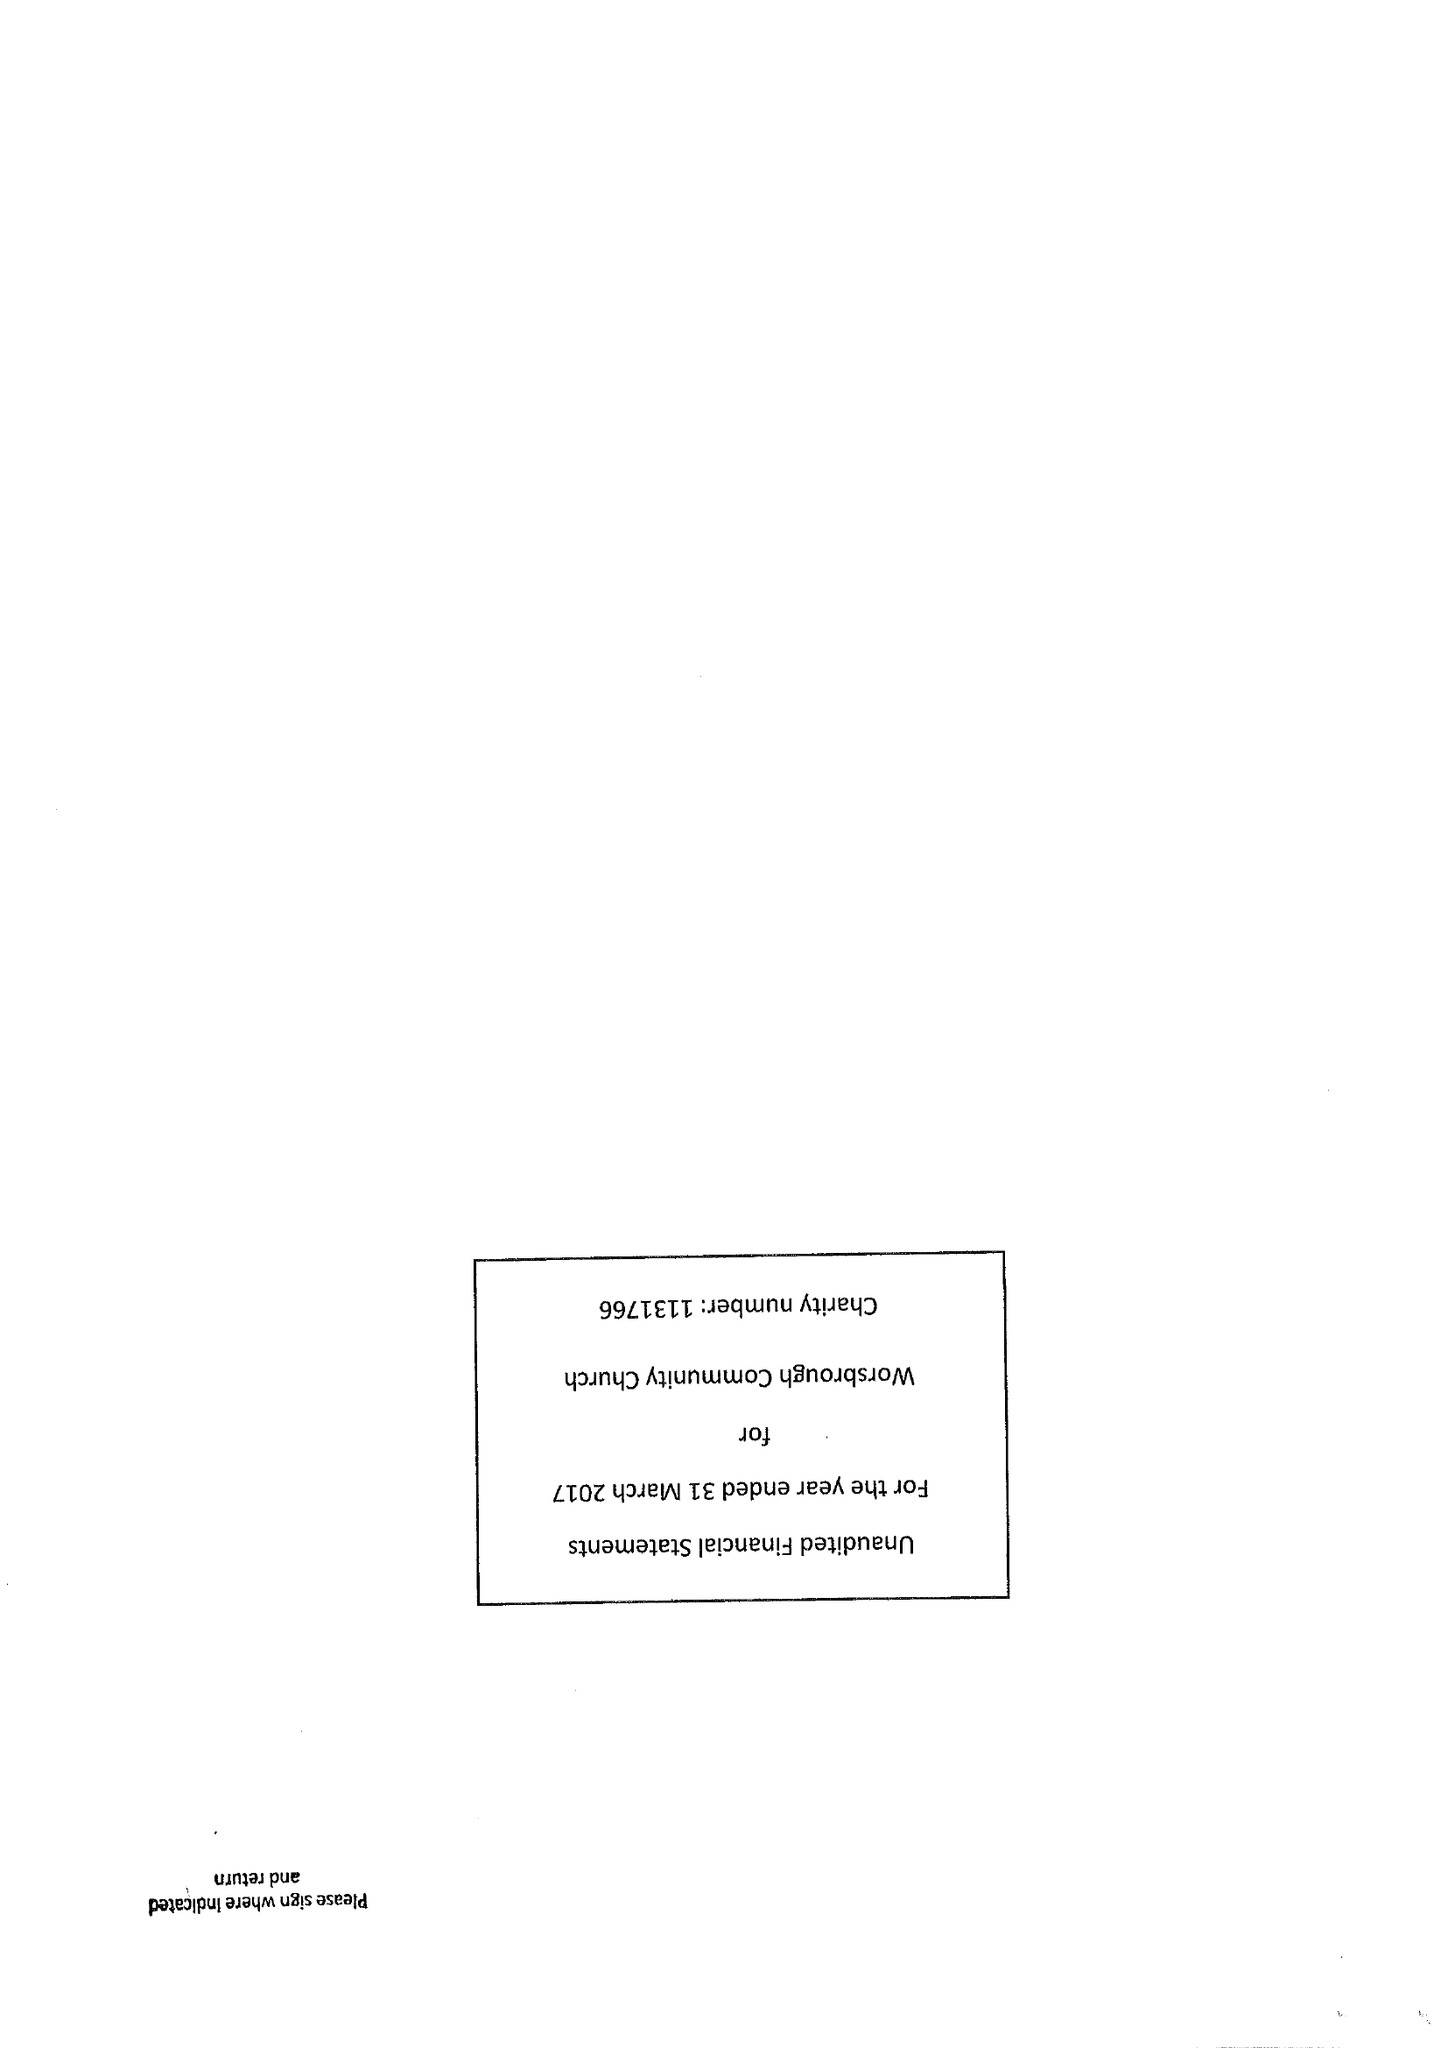What is the value for the income_annually_in_british_pounds?
Answer the question using a single word or phrase. 28138.00 